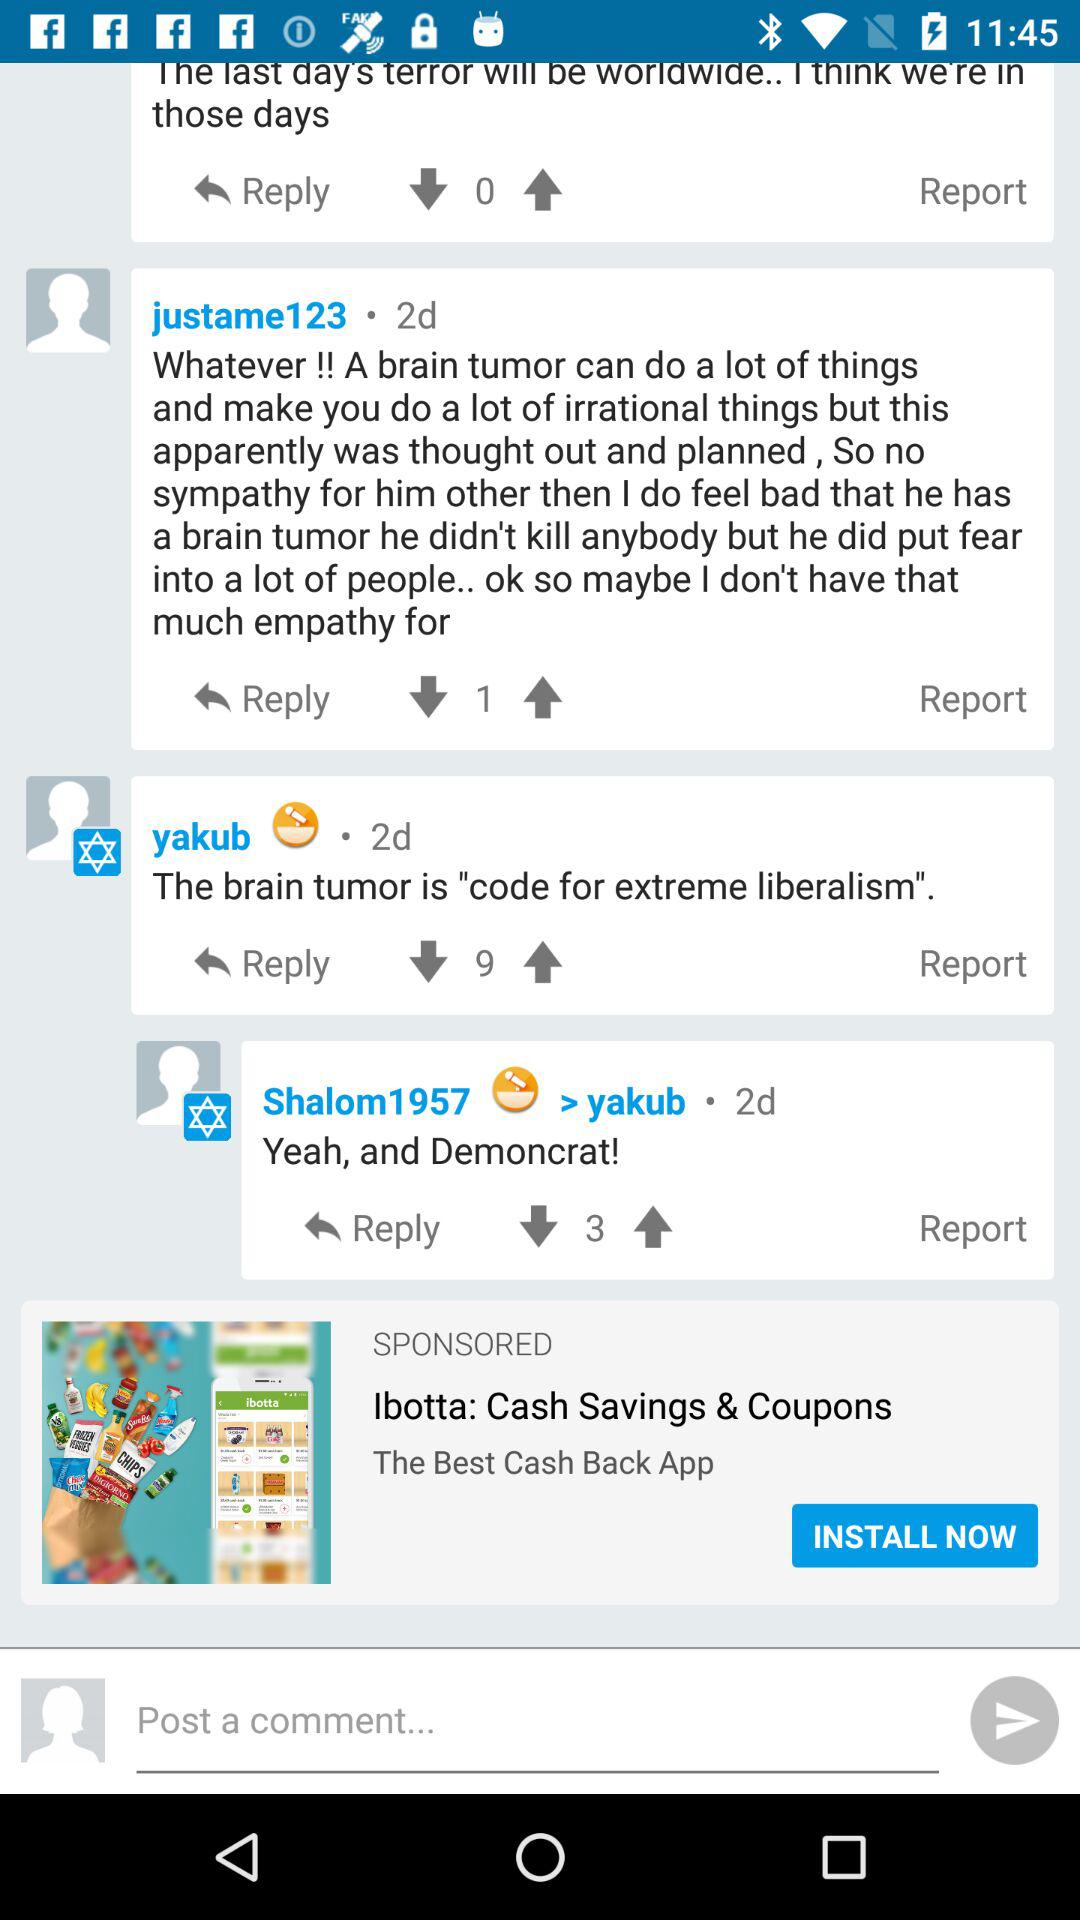What is the login name? The login name is John. 